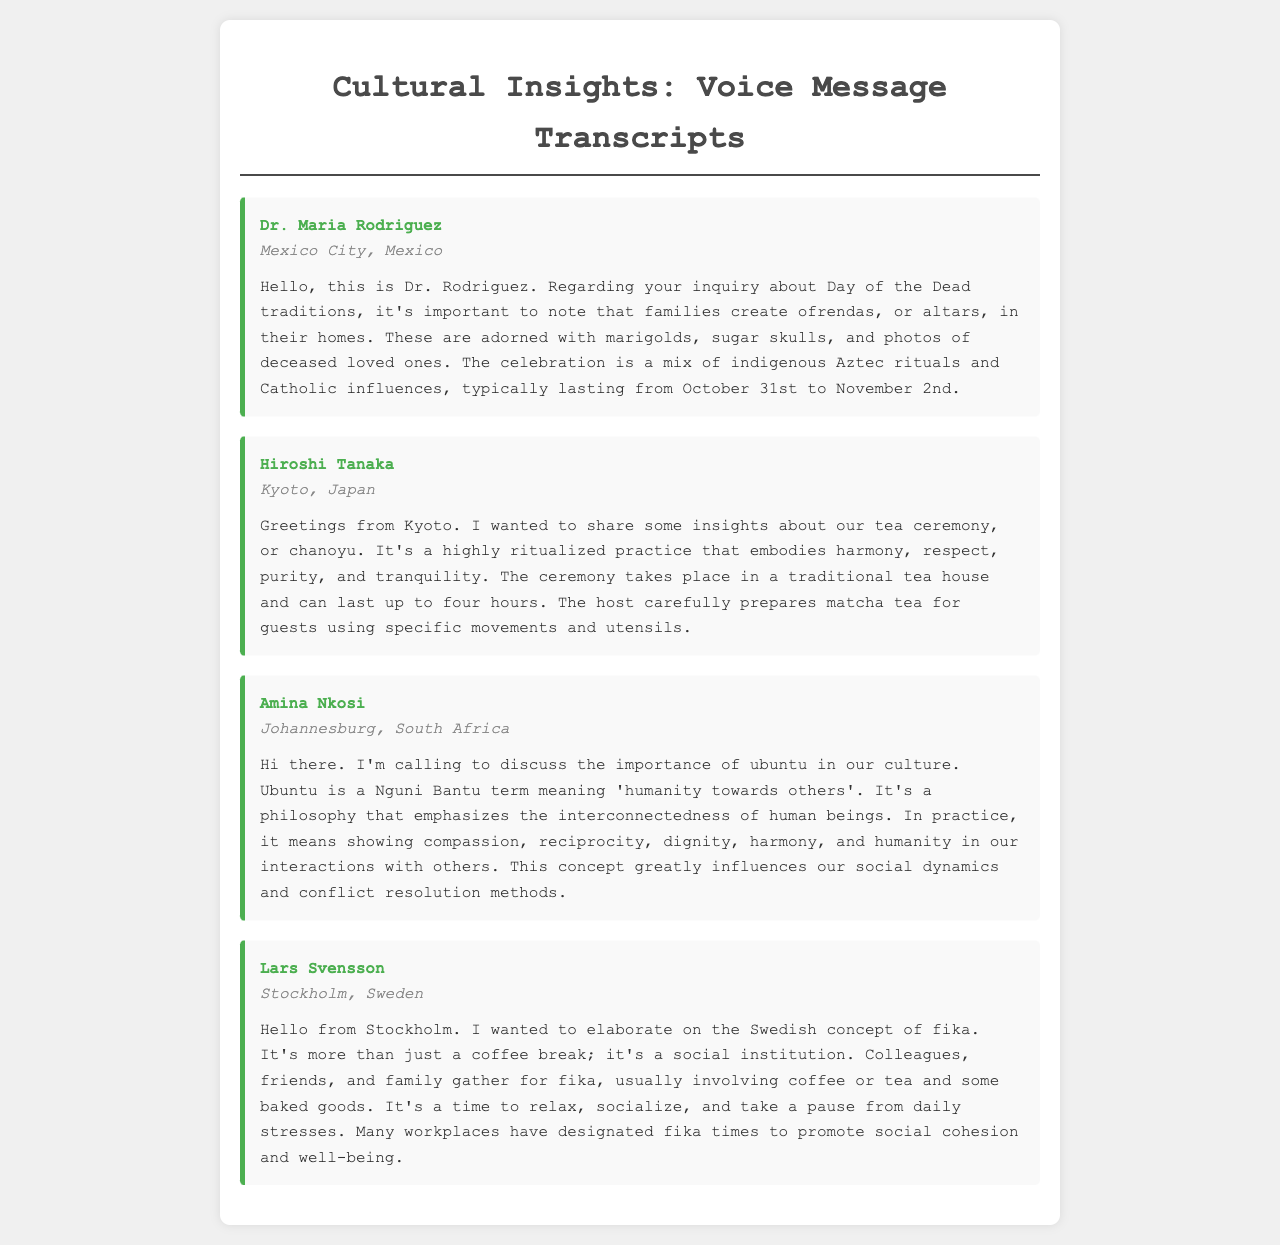What is the significance of ofrendas? The ofrendas, or altars, are significant as they are created to honor deceased loved ones during the Day of the Dead celebrations in Mexico.
Answer: Altars What is the duration of the tea ceremony in Japan? The tea ceremony, or chanoyu, can last up to four hours in Japan.
Answer: Four hours What does ubuntu emphasize in South African culture? Ubuntu emphasizes compassion, reciprocity, dignity, harmony, and humanity in social interactions.
Answer: Interconnectedness Where is the concept of fika practiced? Fika is practiced in Sweden as a social institution during breaks.
Answer: Sweden Who discussed the Day of the Dead traditions? Dr. Maria Rodriguez provided insights on Day of the Dead traditions in her voice message.
Answer: Dr. Maria Rodriguez What flower is commonly used in ofrendas? Marigolds are a commonly used flower in ofrendas for the Day of the Dead.
Answer: Marigolds What is the main beverage served in the Japanese tea ceremony? The main beverage prepared and served during the tea ceremony is matcha tea.
Answer: Matcha tea Which country mentions ancestral rituals influencing their celebration? Mexico mentions indigenous Aztec rituals influencing their Day of the Dead celebration.
Answer: Mexico Who highlighted the importance of ubuntu? Amina Nkosi highlighted the concept of ubuntu in South African culture.
Answer: Amina Nkosi 